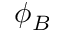<formula> <loc_0><loc_0><loc_500><loc_500>\phi _ { B }</formula> 